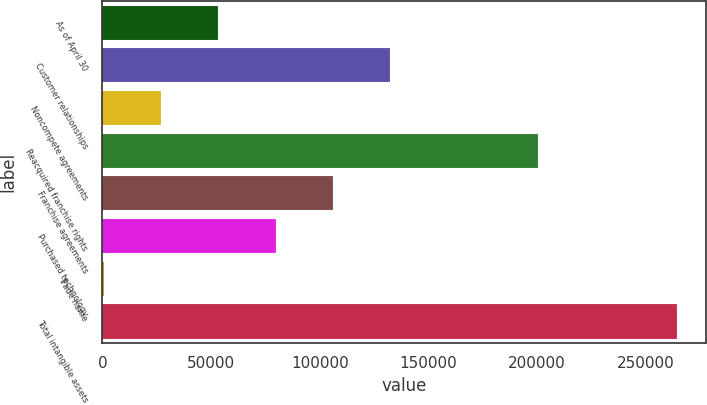<chart> <loc_0><loc_0><loc_500><loc_500><bar_chart><fcel>As of April 30<fcel>Customer relationships<fcel>Noncompete agreements<fcel>Reacquired franchise rights<fcel>Franchise agreements<fcel>Purchased technology<fcel>Trade name<fcel>Total intangible assets<nl><fcel>53290.2<fcel>132476<fcel>26895.1<fcel>200247<fcel>106080<fcel>79685.3<fcel>500<fcel>264451<nl></chart> 